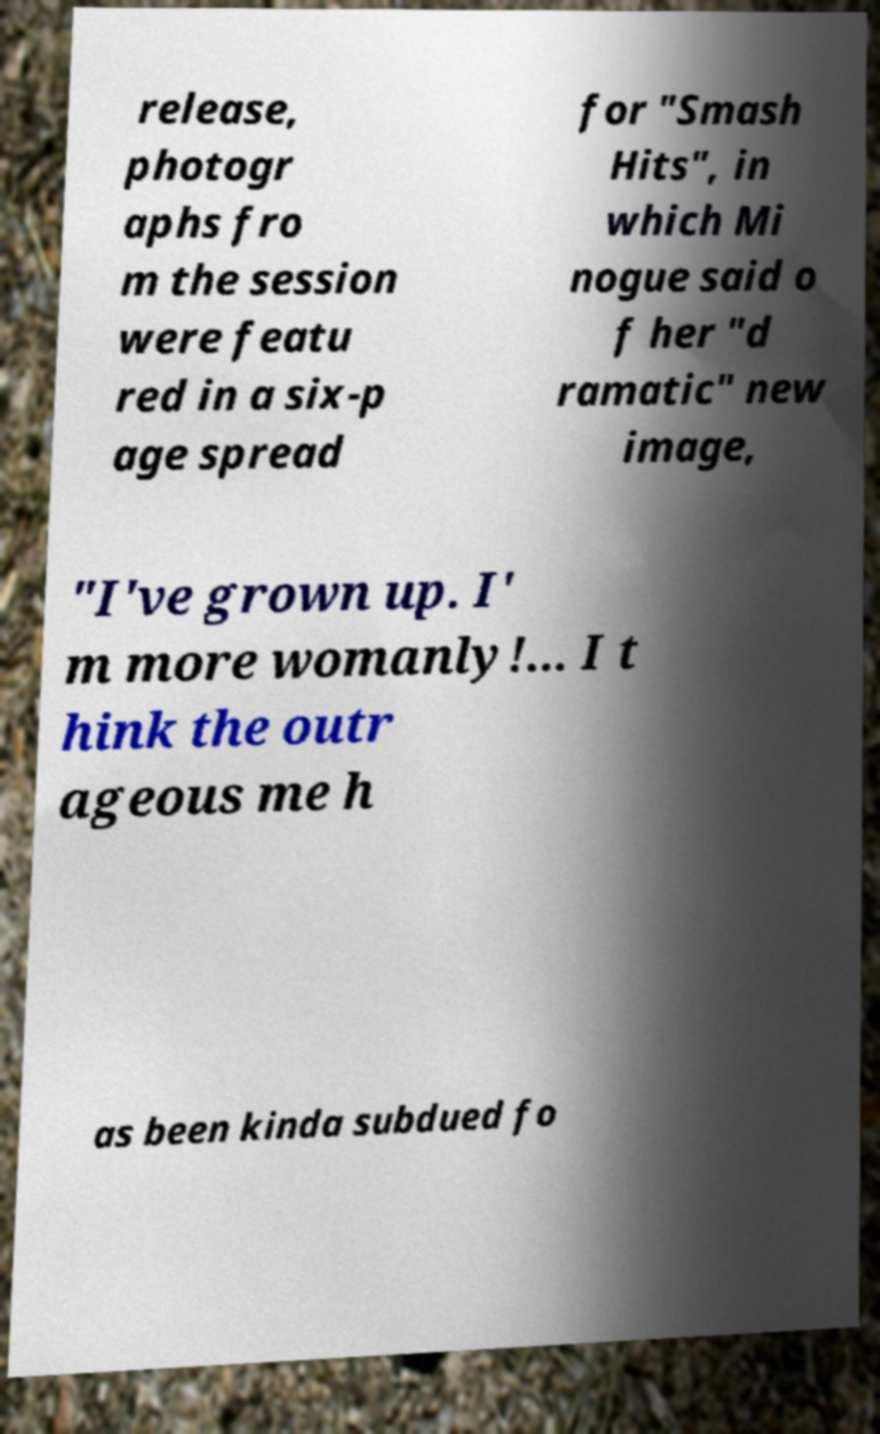I need the written content from this picture converted into text. Can you do that? release, photogr aphs fro m the session were featu red in a six-p age spread for "Smash Hits", in which Mi nogue said o f her "d ramatic" new image, "I've grown up. I' m more womanly!... I t hink the outr ageous me h as been kinda subdued fo 